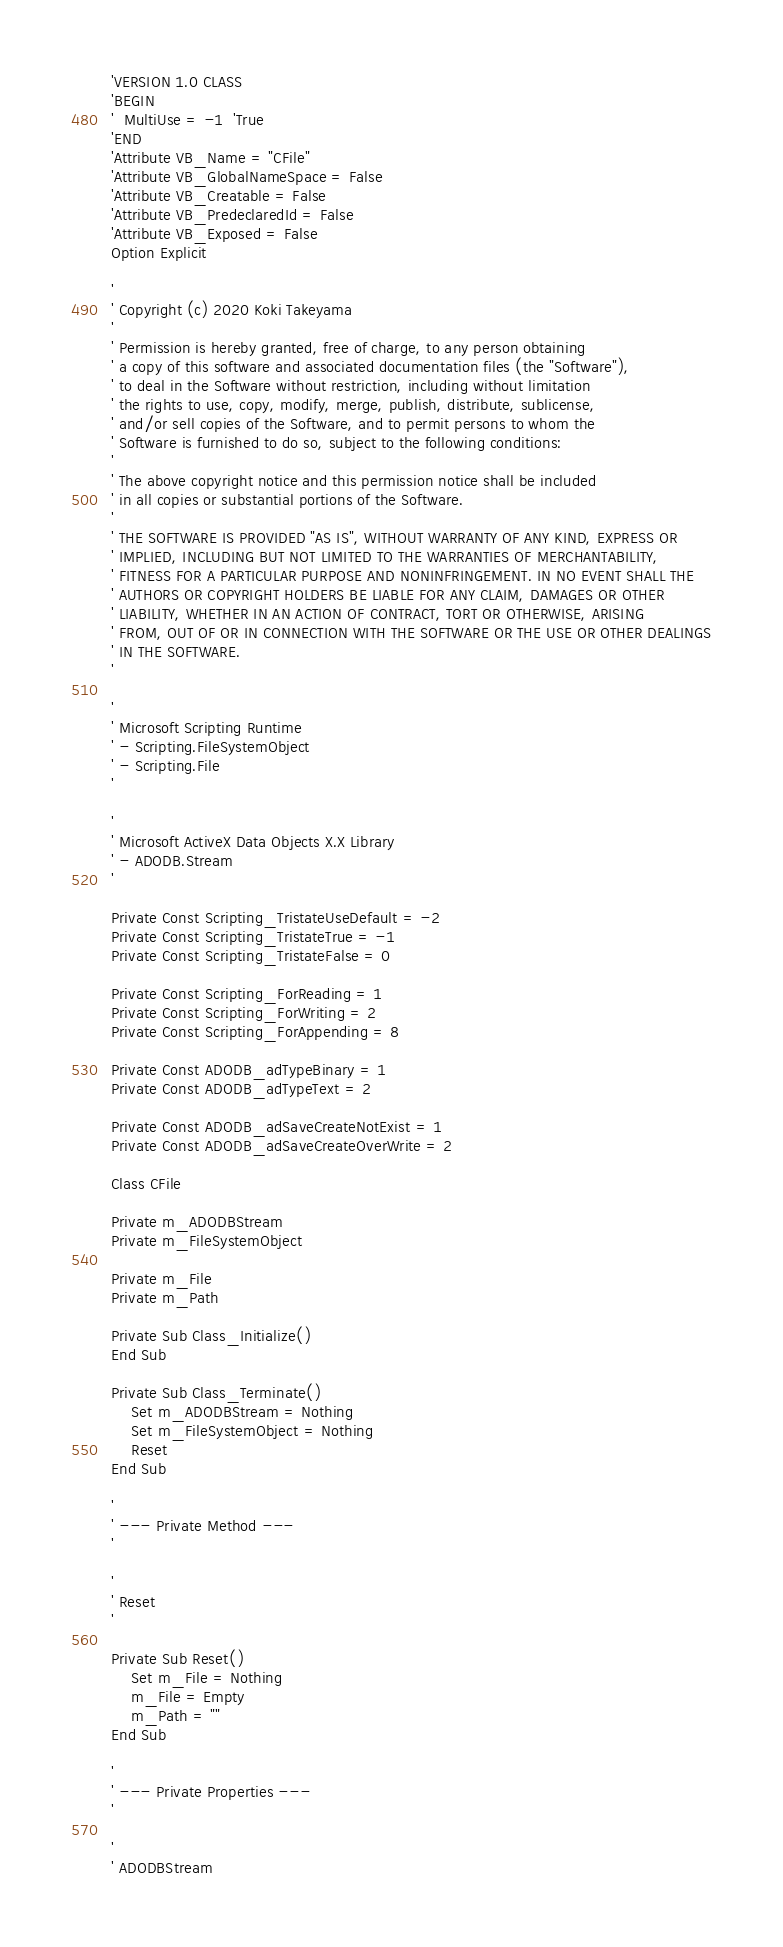Convert code to text. <code><loc_0><loc_0><loc_500><loc_500><_VisualBasic_>'VERSION 1.0 CLASS
'BEGIN
'  MultiUse = -1  'True
'END
'Attribute VB_Name = "CFile"
'Attribute VB_GlobalNameSpace = False
'Attribute VB_Creatable = False
'Attribute VB_PredeclaredId = False
'Attribute VB_Exposed = False
Option Explicit

'
' Copyright (c) 2020 Koki Takeyama
'
' Permission is hereby granted, free of charge, to any person obtaining
' a copy of this software and associated documentation files (the "Software"),
' to deal in the Software without restriction, including without limitation
' the rights to use, copy, modify, merge, publish, distribute, sublicense,
' and/or sell copies of the Software, and to permit persons to whom the
' Software is furnished to do so, subject to the following conditions:
'
' The above copyright notice and this permission notice shall be included
' in all copies or substantial portions of the Software.
'
' THE SOFTWARE IS PROVIDED "AS IS", WITHOUT WARRANTY OF ANY KIND, EXPRESS OR
' IMPLIED, INCLUDING BUT NOT LIMITED TO THE WARRANTIES OF MERCHANTABILITY,
' FITNESS FOR A PARTICULAR PURPOSE AND NONINFRINGEMENT. IN NO EVENT SHALL THE
' AUTHORS OR COPYRIGHT HOLDERS BE LIABLE FOR ANY CLAIM, DAMAGES OR OTHER
' LIABILITY, WHETHER IN AN ACTION OF CONTRACT, TORT OR OTHERWISE, ARISING
' FROM, OUT OF OR IN CONNECTION WITH THE SOFTWARE OR THE USE OR OTHER DEALINGS
' IN THE SOFTWARE.
'

'
' Microsoft Scripting Runtime
' - Scripting.FileSystemObject
' - Scripting.File
'

'
' Microsoft ActiveX Data Objects X.X Library
' - ADODB.Stream
'

Private Const Scripting_TristateUseDefault = -2
Private Const Scripting_TristateTrue = -1
Private Const Scripting_TristateFalse = 0

Private Const Scripting_ForReading = 1
Private Const Scripting_ForWriting = 2
Private Const Scripting_ForAppending = 8

Private Const ADODB_adTypeBinary = 1
Private Const ADODB_adTypeText = 2

Private Const ADODB_adSaveCreateNotExist = 1
Private Const ADODB_adSaveCreateOverWrite = 2

Class CFile

Private m_ADODBStream
Private m_FileSystemObject

Private m_File
Private m_Path

Private Sub Class_Initialize()
End Sub

Private Sub Class_Terminate()
    Set m_ADODBStream = Nothing
    Set m_FileSystemObject = Nothing
    Reset
End Sub

'
' --- Private Method ---
'

'
' Reset
'

Private Sub Reset()
    Set m_File = Nothing
    m_File = Empty
    m_Path = ""
End Sub

'
' --- Private Properties ---
'

'
' ADODBStream</code> 